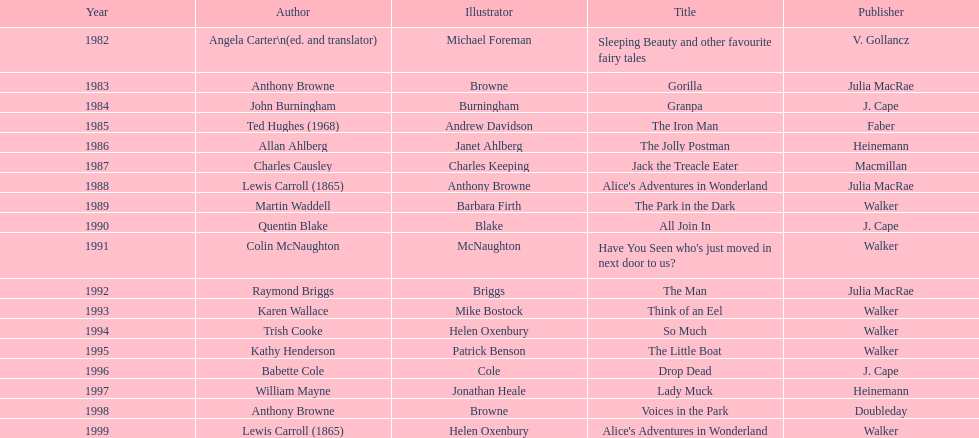Who was the illustrator behind the latest award-winning work? Helen Oxenbury. 